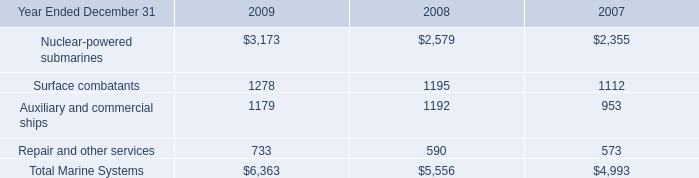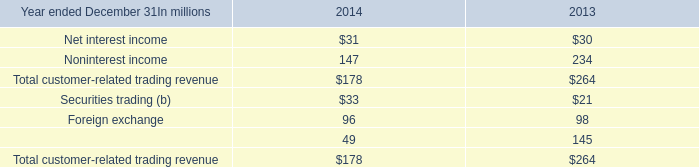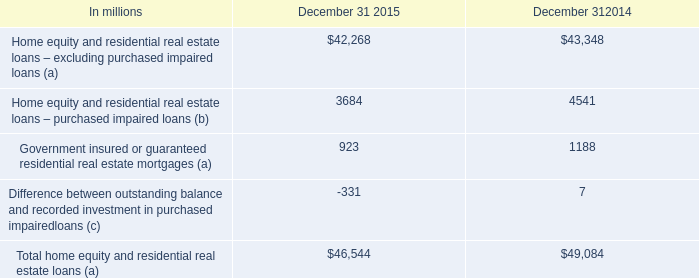Which year is Total home equity and residential real estate loans (a) the least? 
Answer: December 31 2015. 